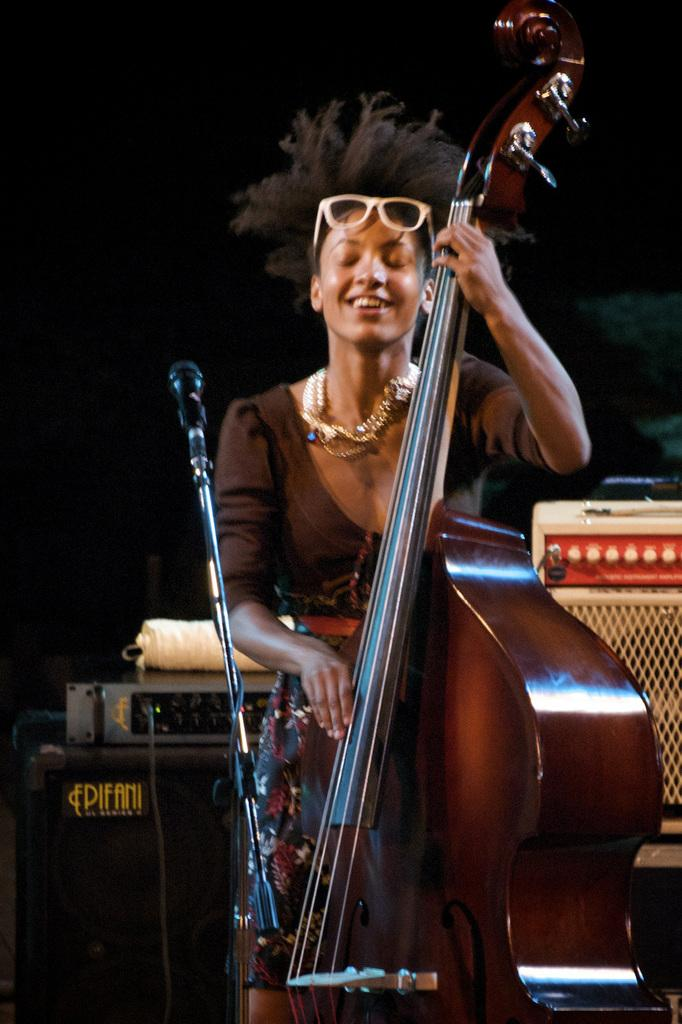Who is the main subject in the image? There is a lady in the image. What is the lady doing in the image? The lady is playing a musical instrument. What is placed in front of the lady? There is a microphone in front of the lady. What can be seen behind the lady in the image? There are electronic objects behind the lady. What type of pan is hanging on the wall behind the lady in the image? There is no pan visible in the image; only electronic objects are present behind the lady. Can you tell me how many baskets are on the floor near the lady? There are no baskets present in the image; the focus is on the lady playing a musical instrument and the electronic objects behind her. 